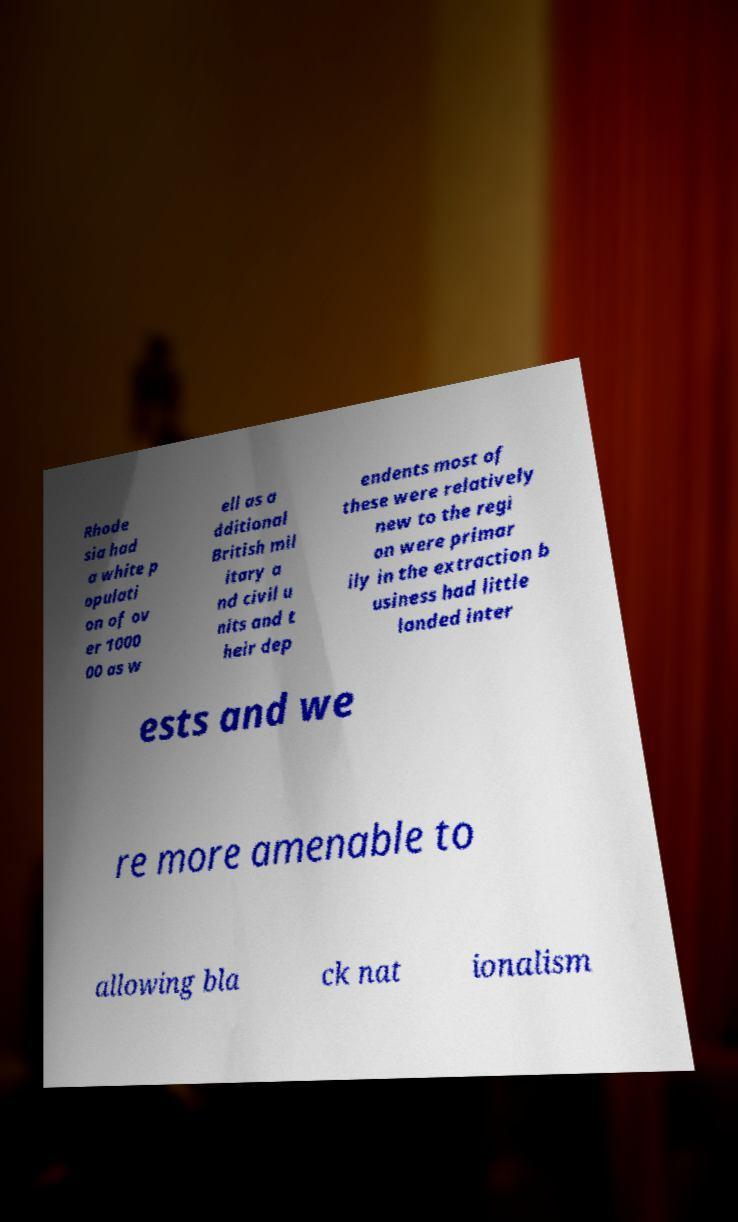Please read and relay the text visible in this image. What does it say? Rhode sia had a white p opulati on of ov er 1000 00 as w ell as a dditional British mil itary a nd civil u nits and t heir dep endents most of these were relatively new to the regi on were primar ily in the extraction b usiness had little landed inter ests and we re more amenable to allowing bla ck nat ionalism 